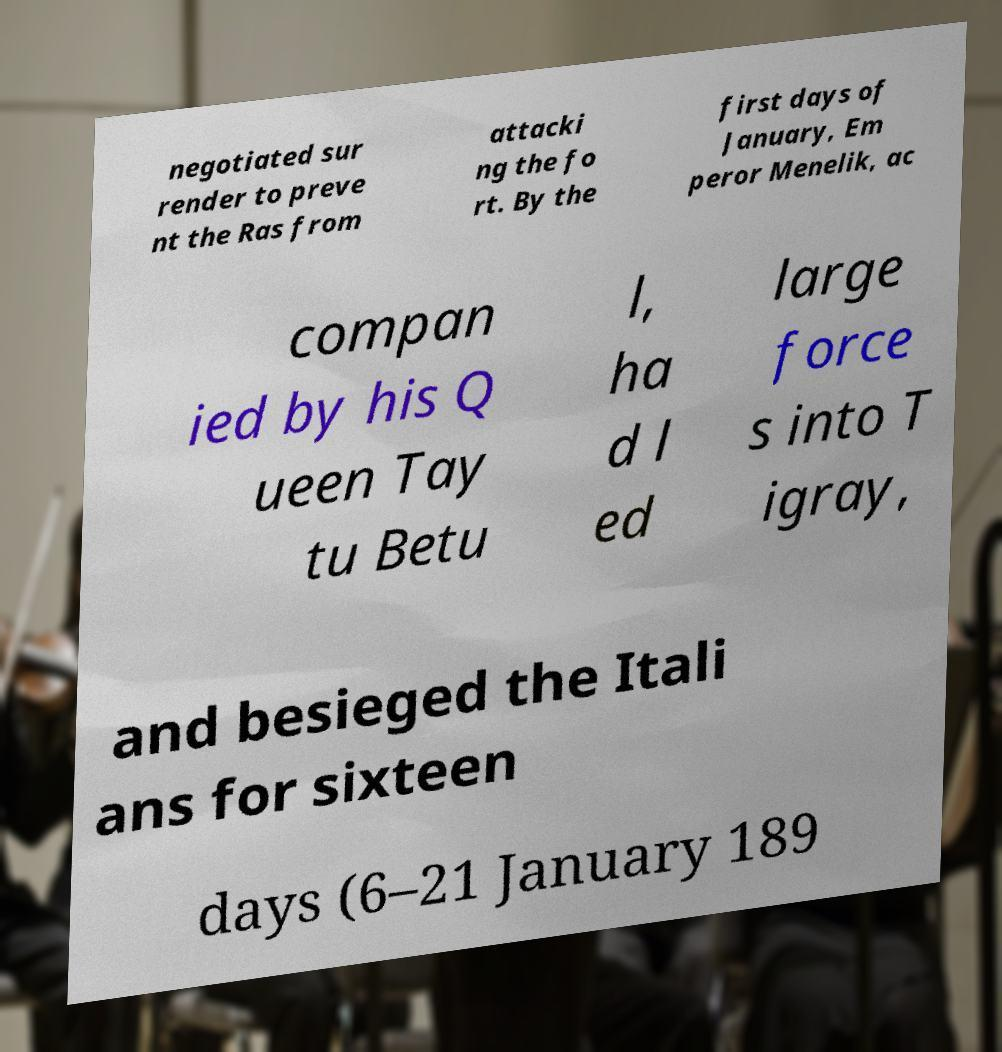Please read and relay the text visible in this image. What does it say? negotiated sur render to preve nt the Ras from attacki ng the fo rt. By the first days of January, Em peror Menelik, ac compan ied by his Q ueen Tay tu Betu l, ha d l ed large force s into T igray, and besieged the Itali ans for sixteen days (6–21 January 189 